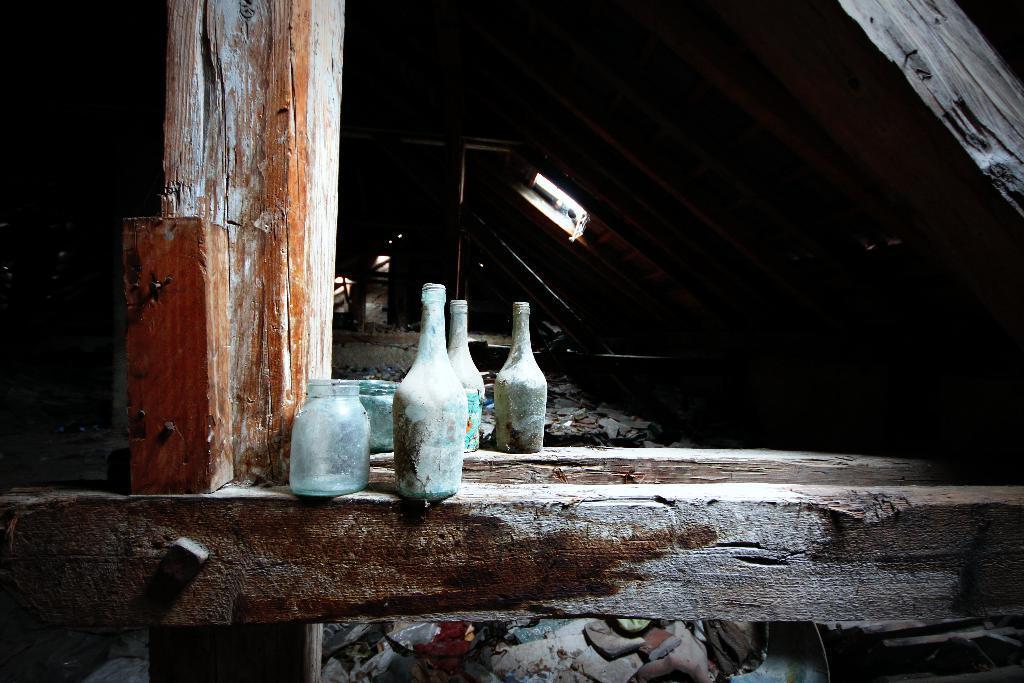Describe this image in one or two sentences. In this image we can see three bottles and two jars placed on wooden log. 